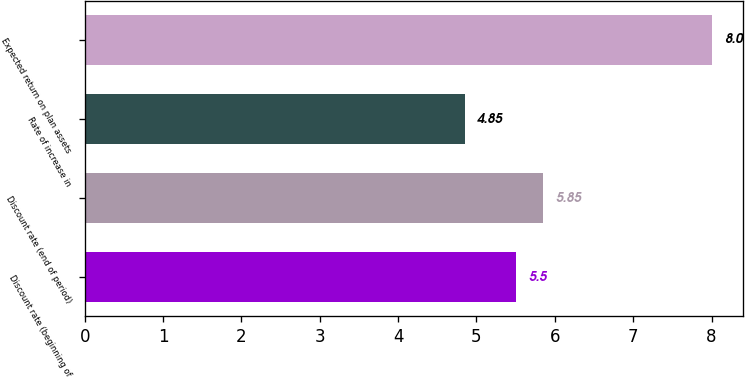Convert chart to OTSL. <chart><loc_0><loc_0><loc_500><loc_500><bar_chart><fcel>Discount rate (beginning of<fcel>Discount rate (end of period)<fcel>Rate of increase in<fcel>Expected return on plan assets<nl><fcel>5.5<fcel>5.85<fcel>4.85<fcel>8<nl></chart> 